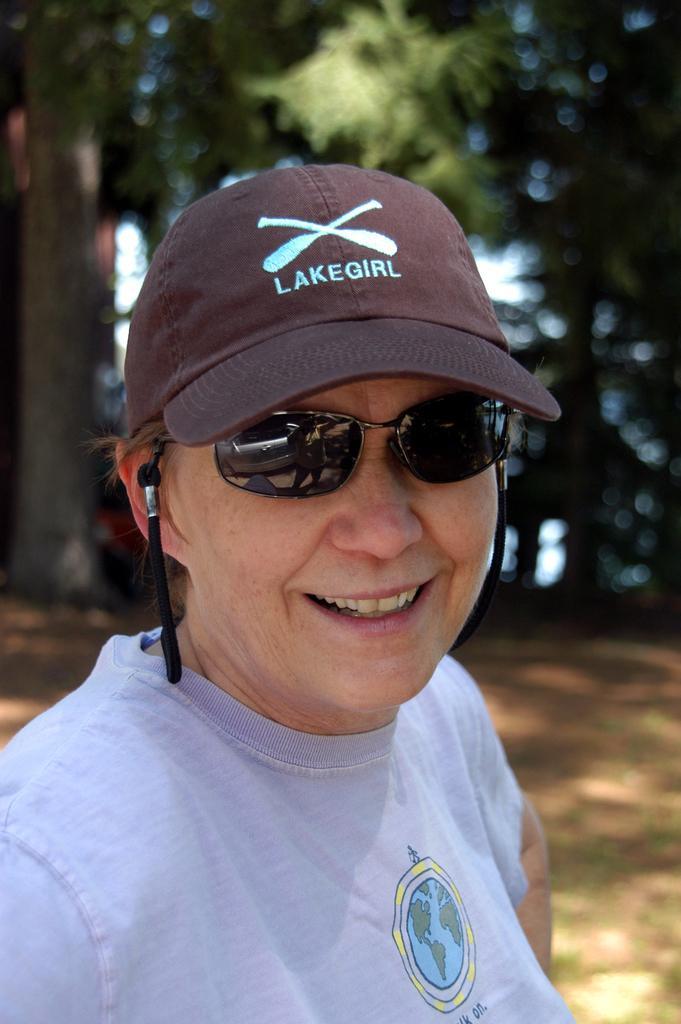Describe this image in one or two sentences. There is one person at the bottom of this image is wearing a goggles and a cap, and there are some trees in the background. 